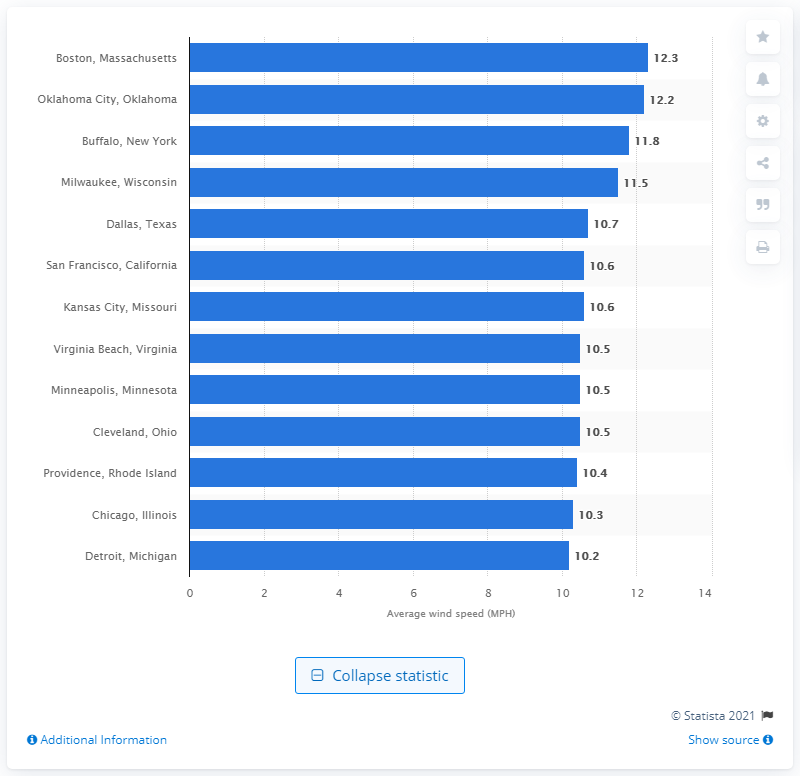Highlight a few significant elements in this photo. The average wind speed in a certain city was 10.3 miles per hour. That city was Chicago, Illinois. 